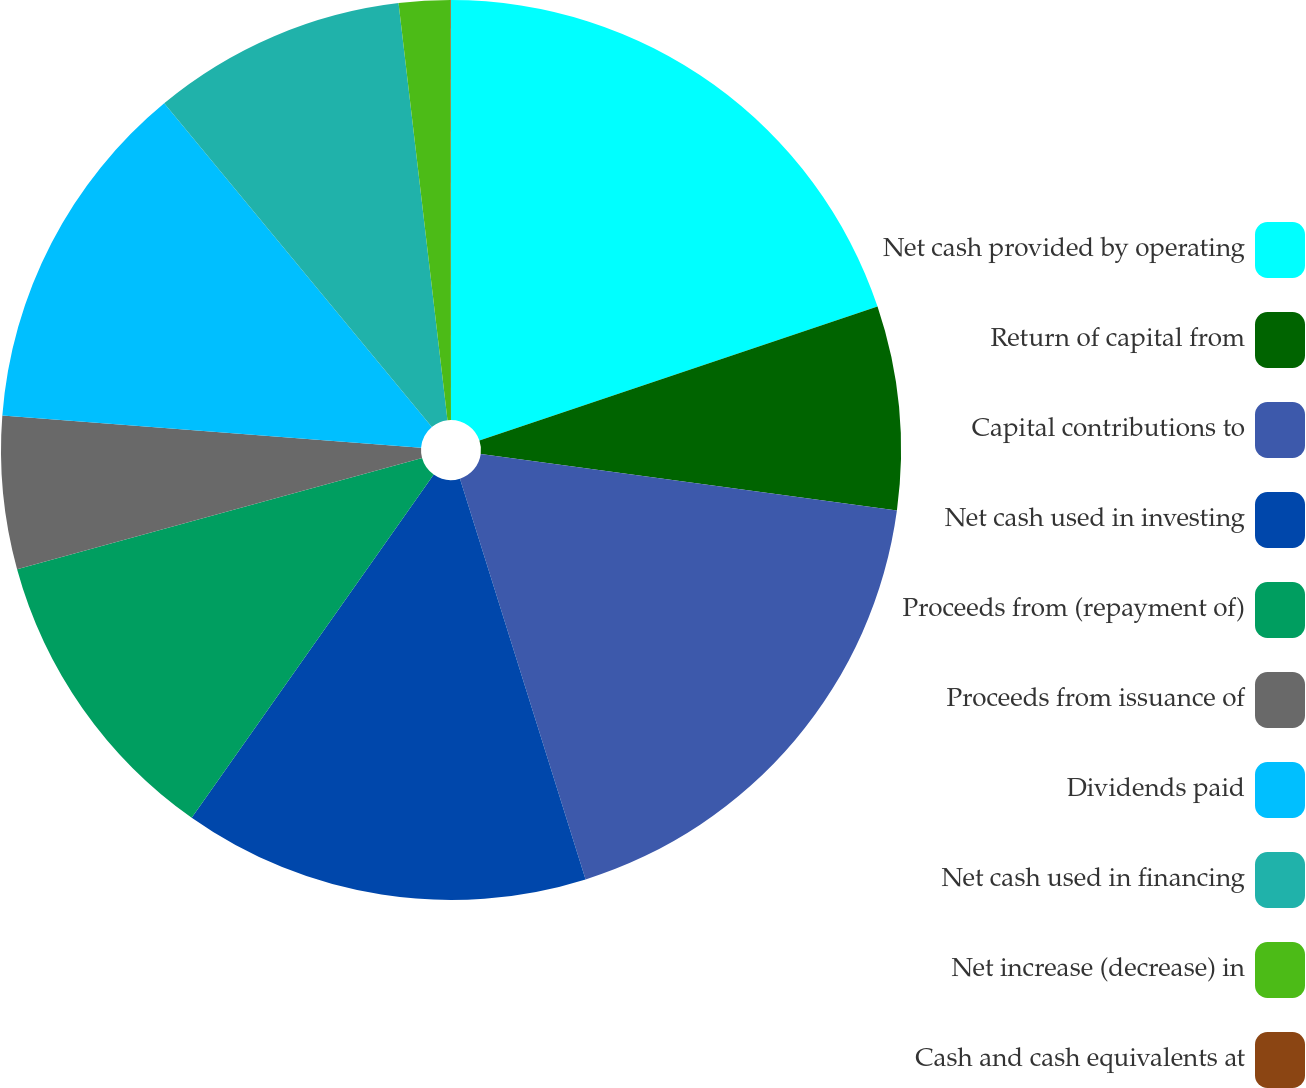<chart> <loc_0><loc_0><loc_500><loc_500><pie_chart><fcel>Net cash provided by operating<fcel>Return of capital from<fcel>Capital contributions to<fcel>Net cash used in investing<fcel>Proceeds from (repayment of)<fcel>Proceeds from issuance of<fcel>Dividends paid<fcel>Net cash used in financing<fcel>Net increase (decrease) in<fcel>Cash and cash equivalents at<nl><fcel>19.84%<fcel>7.31%<fcel>18.02%<fcel>14.61%<fcel>10.96%<fcel>5.49%<fcel>12.78%<fcel>9.14%<fcel>1.84%<fcel>0.02%<nl></chart> 